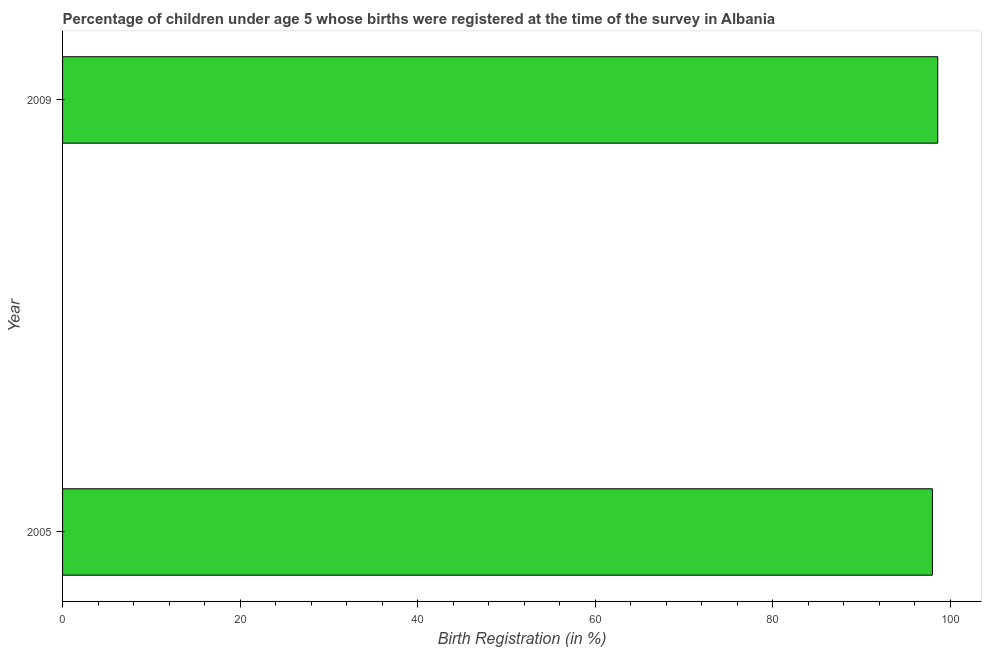Does the graph contain any zero values?
Your answer should be very brief. No. Does the graph contain grids?
Provide a succinct answer. No. What is the title of the graph?
Make the answer very short. Percentage of children under age 5 whose births were registered at the time of the survey in Albania. What is the label or title of the X-axis?
Keep it short and to the point. Birth Registration (in %). What is the label or title of the Y-axis?
Offer a terse response. Year. What is the birth registration in 2005?
Give a very brief answer. 98. Across all years, what is the maximum birth registration?
Offer a very short reply. 98.6. Across all years, what is the minimum birth registration?
Provide a succinct answer. 98. What is the sum of the birth registration?
Provide a short and direct response. 196.6. What is the difference between the birth registration in 2005 and 2009?
Your answer should be very brief. -0.6. What is the average birth registration per year?
Your response must be concise. 98.3. What is the median birth registration?
Provide a short and direct response. 98.3. In how many years, is the birth registration greater than 20 %?
Your answer should be very brief. 2. Is the birth registration in 2005 less than that in 2009?
Provide a short and direct response. Yes. How many bars are there?
Your response must be concise. 2. Are all the bars in the graph horizontal?
Your answer should be compact. Yes. How many years are there in the graph?
Provide a short and direct response. 2. What is the difference between two consecutive major ticks on the X-axis?
Your answer should be compact. 20. Are the values on the major ticks of X-axis written in scientific E-notation?
Ensure brevity in your answer.  No. What is the Birth Registration (in %) in 2005?
Provide a succinct answer. 98. What is the Birth Registration (in %) in 2009?
Give a very brief answer. 98.6. What is the difference between the Birth Registration (in %) in 2005 and 2009?
Ensure brevity in your answer.  -0.6. What is the ratio of the Birth Registration (in %) in 2005 to that in 2009?
Keep it short and to the point. 0.99. 